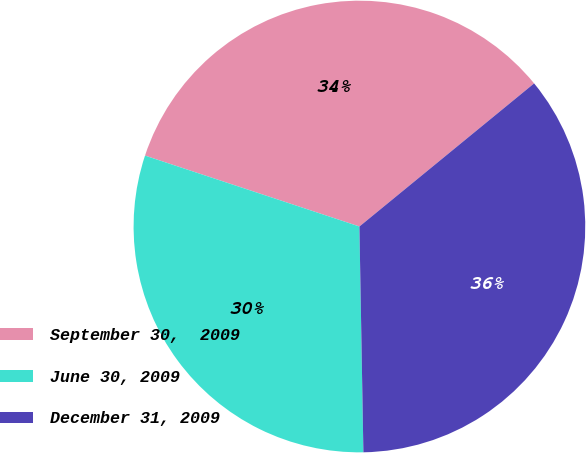Convert chart. <chart><loc_0><loc_0><loc_500><loc_500><pie_chart><fcel>September 30,  2009<fcel>June 30, 2009<fcel>December 31, 2009<nl><fcel>33.99%<fcel>30.36%<fcel>35.64%<nl></chart> 